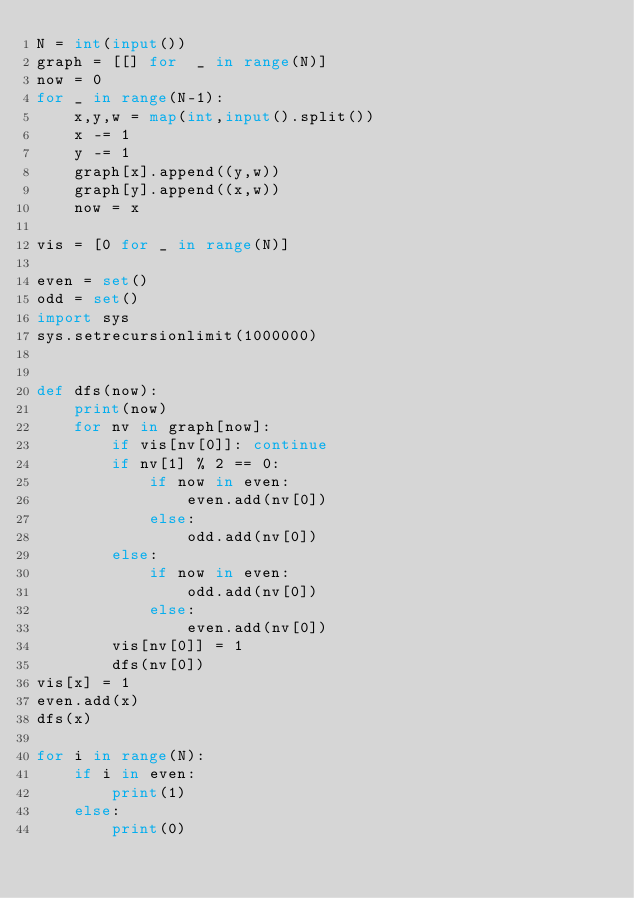Convert code to text. <code><loc_0><loc_0><loc_500><loc_500><_Python_>N = int(input())
graph = [[] for  _ in range(N)]
now = 0
for _ in range(N-1):
    x,y,w = map(int,input().split())
    x -= 1
    y -= 1
    graph[x].append((y,w))
    graph[y].append((x,w))
    now = x
    
vis = [0 for _ in range(N)]

even = set()
odd = set()
import sys
sys.setrecursionlimit(1000000)


def dfs(now):
    print(now)
    for nv in graph[now]:
        if vis[nv[0]]: continue
        if nv[1] % 2 == 0:
            if now in even:
                even.add(nv[0])
            else:
                odd.add(nv[0])
        else:
            if now in even:
                odd.add(nv[0])
            else:
                even.add(nv[0])
        vis[nv[0]] = 1
        dfs(nv[0])
vis[x] = 1
even.add(x)
dfs(x)

for i in range(N):
    if i in even:
        print(1)
    else:
        print(0)

</code> 